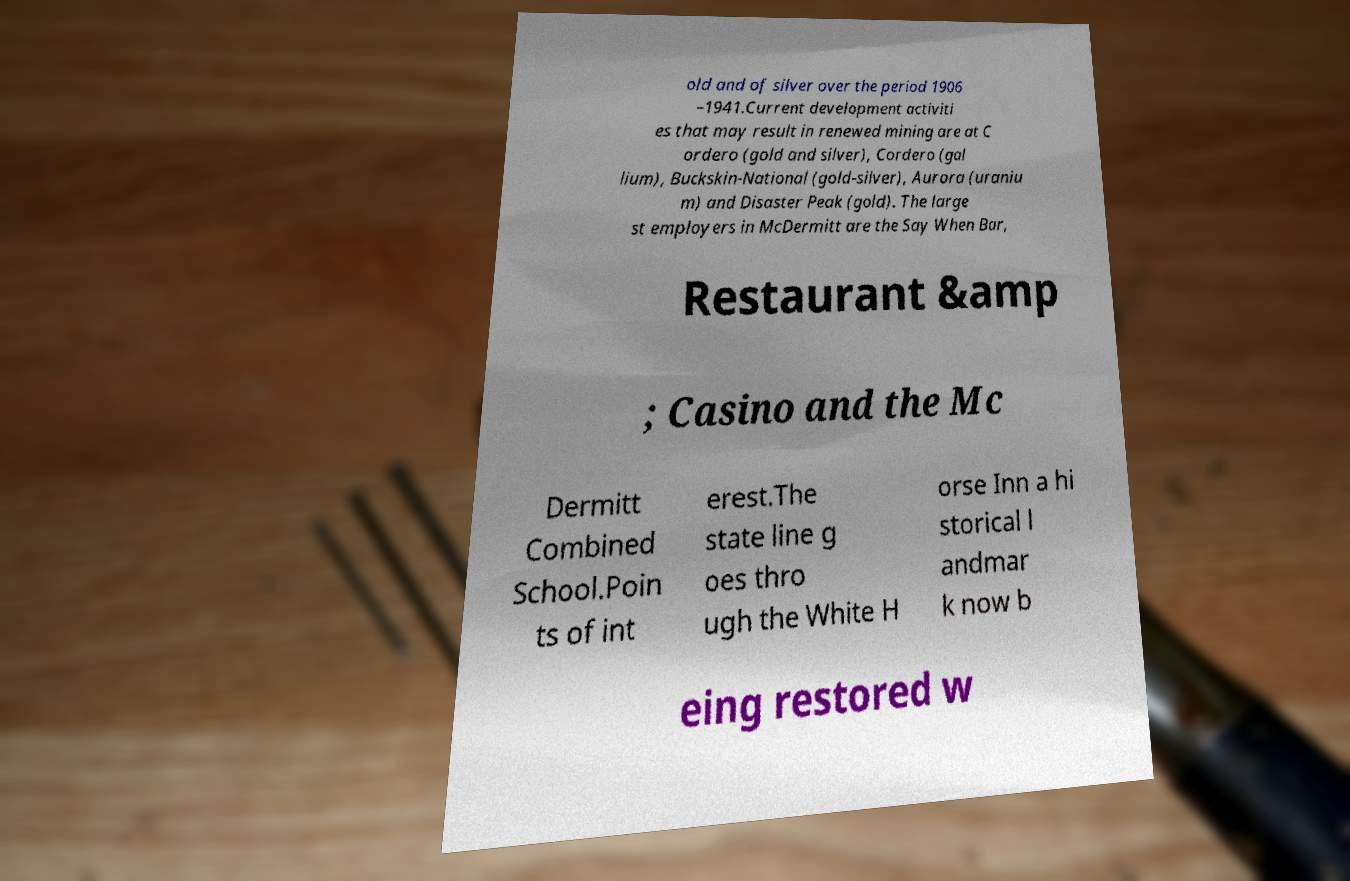Could you extract and type out the text from this image? old and of silver over the period 1906 –1941.Current development activiti es that may result in renewed mining are at C ordero (gold and silver), Cordero (gal lium), Buckskin-National (gold-silver), Aurora (uraniu m) and Disaster Peak (gold). The large st employers in McDermitt are the Say When Bar, Restaurant &amp ; Casino and the Mc Dermitt Combined School.Poin ts of int erest.The state line g oes thro ugh the White H orse Inn a hi storical l andmar k now b eing restored w 